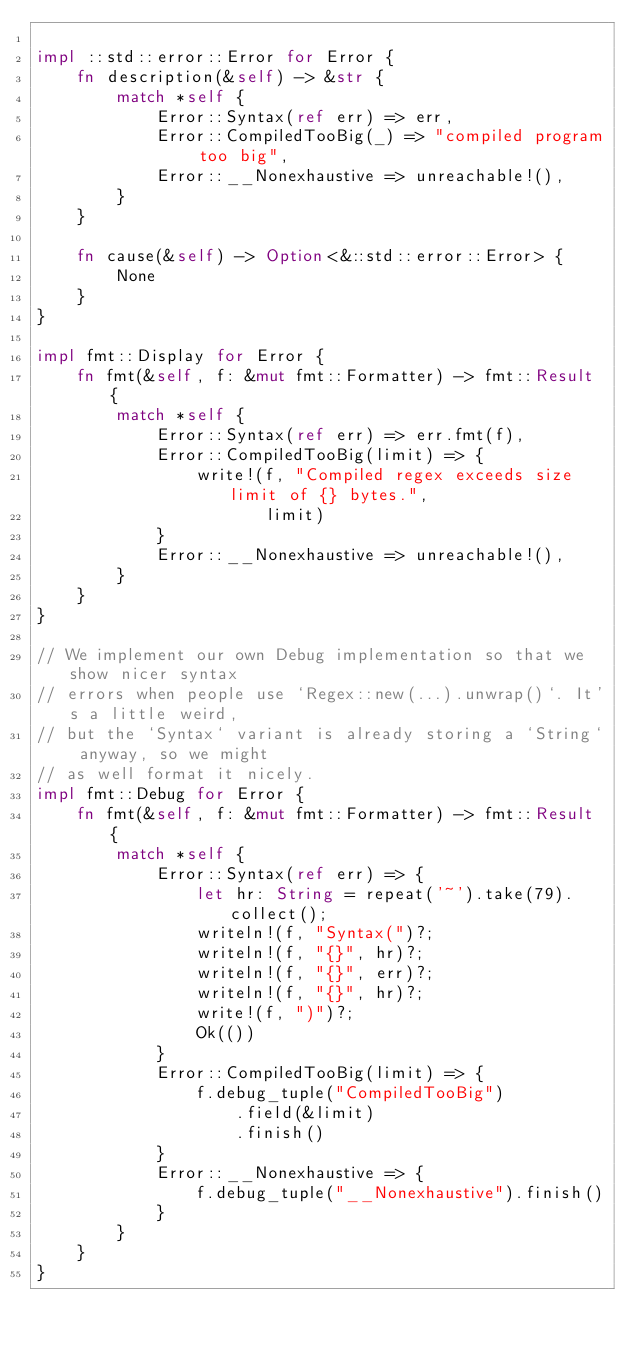<code> <loc_0><loc_0><loc_500><loc_500><_Rust_>
impl ::std::error::Error for Error {
    fn description(&self) -> &str {
        match *self {
            Error::Syntax(ref err) => err,
            Error::CompiledTooBig(_) => "compiled program too big",
            Error::__Nonexhaustive => unreachable!(),
        }
    }

    fn cause(&self) -> Option<&::std::error::Error> {
        None
    }
}

impl fmt::Display for Error {
    fn fmt(&self, f: &mut fmt::Formatter) -> fmt::Result {
        match *self {
            Error::Syntax(ref err) => err.fmt(f),
            Error::CompiledTooBig(limit) => {
                write!(f, "Compiled regex exceeds size limit of {} bytes.",
                       limit)
            }
            Error::__Nonexhaustive => unreachable!(),
        }
    }
}

// We implement our own Debug implementation so that we show nicer syntax
// errors when people use `Regex::new(...).unwrap()`. It's a little weird,
// but the `Syntax` variant is already storing a `String` anyway, so we might
// as well format it nicely.
impl fmt::Debug for Error {
    fn fmt(&self, f: &mut fmt::Formatter) -> fmt::Result {
        match *self {
            Error::Syntax(ref err) => {
                let hr: String = repeat('~').take(79).collect();
                writeln!(f, "Syntax(")?;
                writeln!(f, "{}", hr)?;
                writeln!(f, "{}", err)?;
                writeln!(f, "{}", hr)?;
                write!(f, ")")?;
                Ok(())
            }
            Error::CompiledTooBig(limit) => {
                f.debug_tuple("CompiledTooBig")
                    .field(&limit)
                    .finish()
            }
            Error::__Nonexhaustive => {
                f.debug_tuple("__Nonexhaustive").finish()
            }
        }
    }
}
</code> 